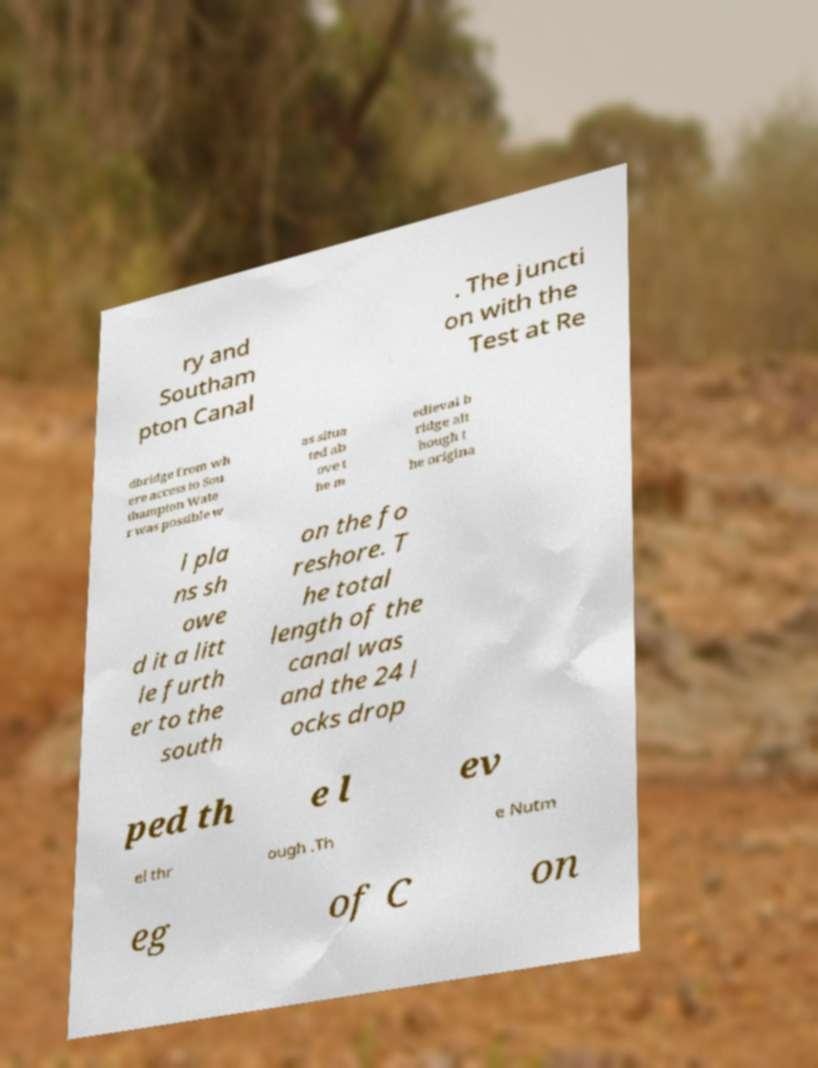Please identify and transcribe the text found in this image. ry and Southam pton Canal . The juncti on with the Test at Re dbridge from wh ere access to Sou thampton Wate r was possible w as situa ted ab ove t he m edieval b ridge alt hough t he origina l pla ns sh owe d it a litt le furth er to the south on the fo reshore. T he total length of the canal was and the 24 l ocks drop ped th e l ev el thr ough .Th e Nutm eg of C on 